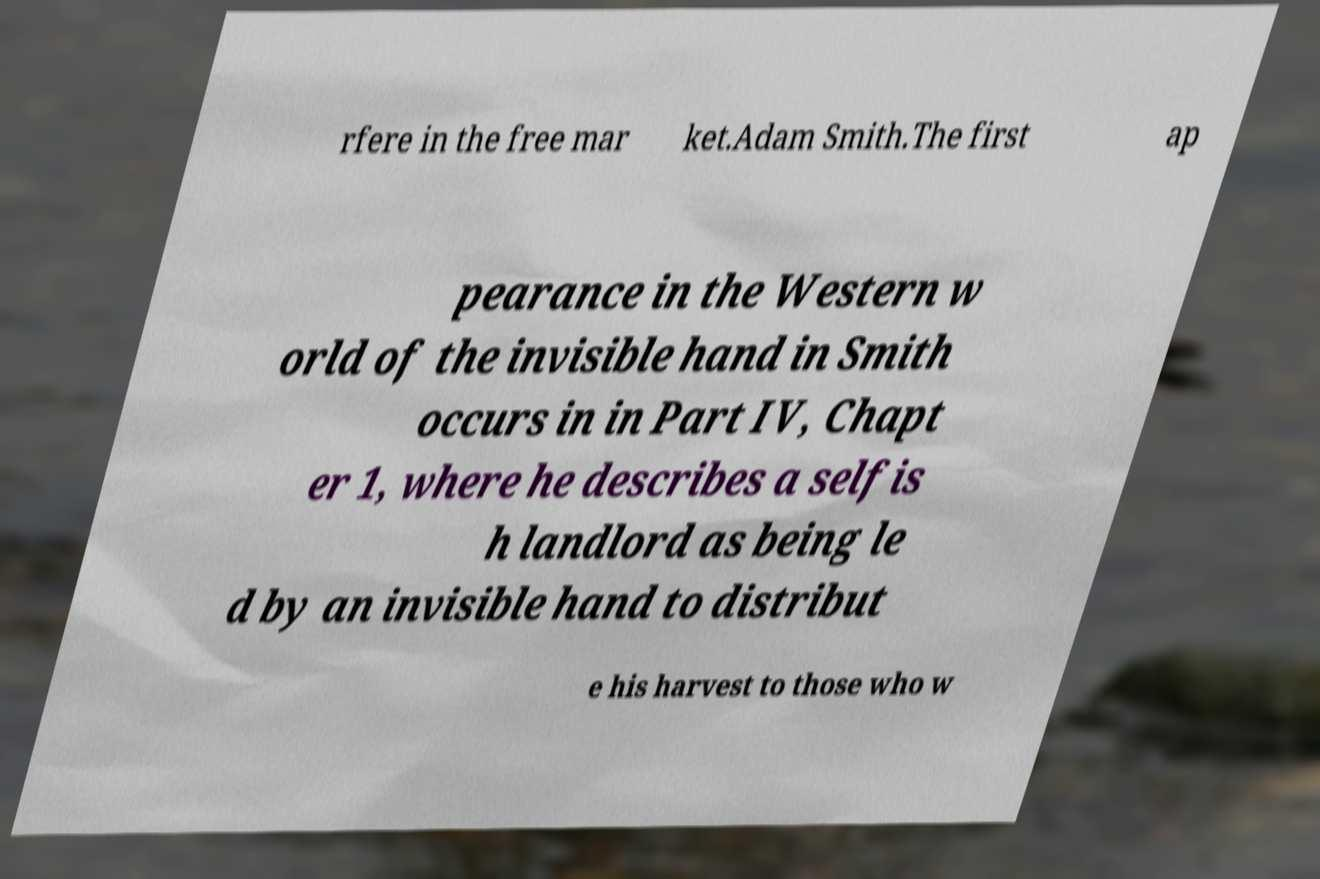Can you read and provide the text displayed in the image?This photo seems to have some interesting text. Can you extract and type it out for me? rfere in the free mar ket.Adam Smith.The first ap pearance in the Western w orld of the invisible hand in Smith occurs in in Part IV, Chapt er 1, where he describes a selfis h landlord as being le d by an invisible hand to distribut e his harvest to those who w 